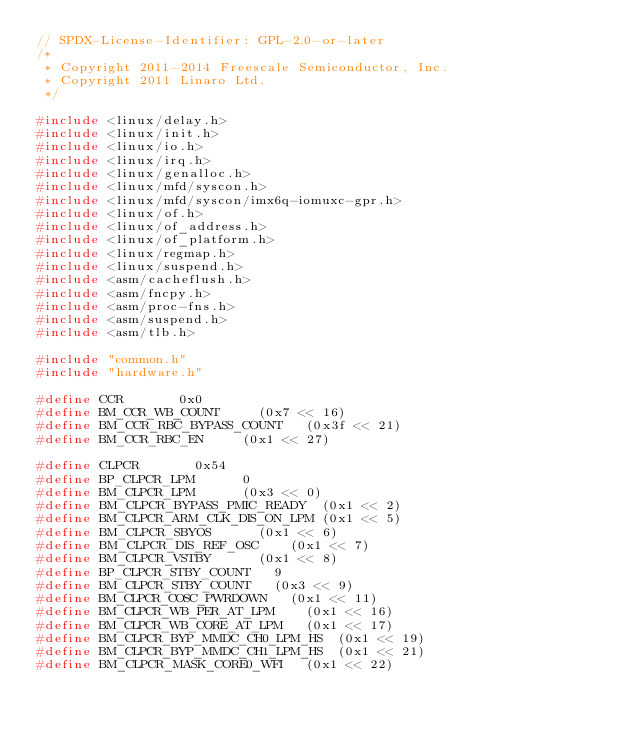<code> <loc_0><loc_0><loc_500><loc_500><_C_>// SPDX-License-Identifier: GPL-2.0-or-later
/*
 * Copyright 2011-2014 Freescale Semiconductor, Inc.
 * Copyright 2011 Linaro Ltd.
 */

#include <linux/delay.h>
#include <linux/init.h>
#include <linux/io.h>
#include <linux/irq.h>
#include <linux/genalloc.h>
#include <linux/mfd/syscon.h>
#include <linux/mfd/syscon/imx6q-iomuxc-gpr.h>
#include <linux/of.h>
#include <linux/of_address.h>
#include <linux/of_platform.h>
#include <linux/regmap.h>
#include <linux/suspend.h>
#include <asm/cacheflush.h>
#include <asm/fncpy.h>
#include <asm/proc-fns.h>
#include <asm/suspend.h>
#include <asm/tlb.h>

#include "common.h"
#include "hardware.h"

#define CCR				0x0
#define BM_CCR_WB_COUNT			(0x7 << 16)
#define BM_CCR_RBC_BYPASS_COUNT		(0x3f << 21)
#define BM_CCR_RBC_EN			(0x1 << 27)

#define CLPCR				0x54
#define BP_CLPCR_LPM			0
#define BM_CLPCR_LPM			(0x3 << 0)
#define BM_CLPCR_BYPASS_PMIC_READY	(0x1 << 2)
#define BM_CLPCR_ARM_CLK_DIS_ON_LPM	(0x1 << 5)
#define BM_CLPCR_SBYOS			(0x1 << 6)
#define BM_CLPCR_DIS_REF_OSC		(0x1 << 7)
#define BM_CLPCR_VSTBY			(0x1 << 8)
#define BP_CLPCR_STBY_COUNT		9
#define BM_CLPCR_STBY_COUNT		(0x3 << 9)
#define BM_CLPCR_COSC_PWRDOWN		(0x1 << 11)
#define BM_CLPCR_WB_PER_AT_LPM		(0x1 << 16)
#define BM_CLPCR_WB_CORE_AT_LPM		(0x1 << 17)
#define BM_CLPCR_BYP_MMDC_CH0_LPM_HS	(0x1 << 19)
#define BM_CLPCR_BYP_MMDC_CH1_LPM_HS	(0x1 << 21)
#define BM_CLPCR_MASK_CORE0_WFI		(0x1 << 22)</code> 